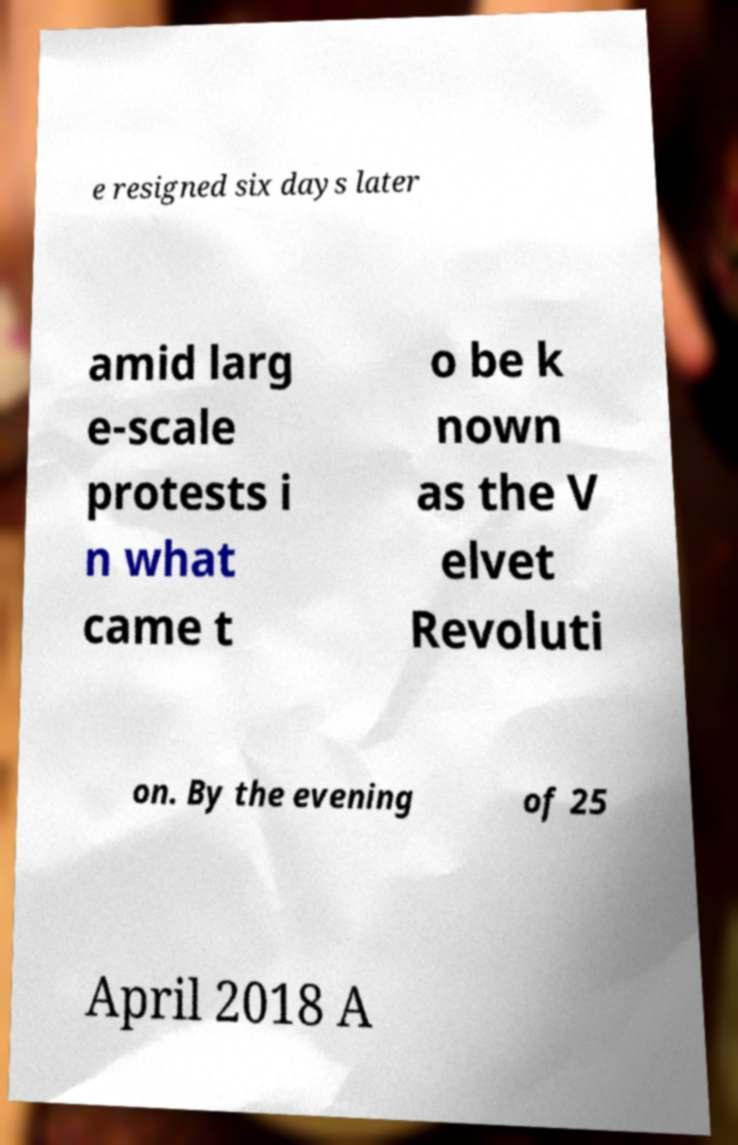There's text embedded in this image that I need extracted. Can you transcribe it verbatim? e resigned six days later amid larg e-scale protests i n what came t o be k nown as the V elvet Revoluti on. By the evening of 25 April 2018 A 